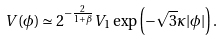Convert formula to latex. <formula><loc_0><loc_0><loc_500><loc_500>V ( \phi ) \simeq { 2 ^ { - \frac { 2 } { 1 + \beta } } } V _ { 1 } \exp \left ( - \sqrt { 3 } \kappa | \phi | \right ) .</formula> 